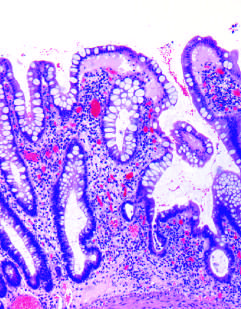what does haphazard crypt organization result from?
Answer the question using a single word or phrase. Repeated injury and regeneration 